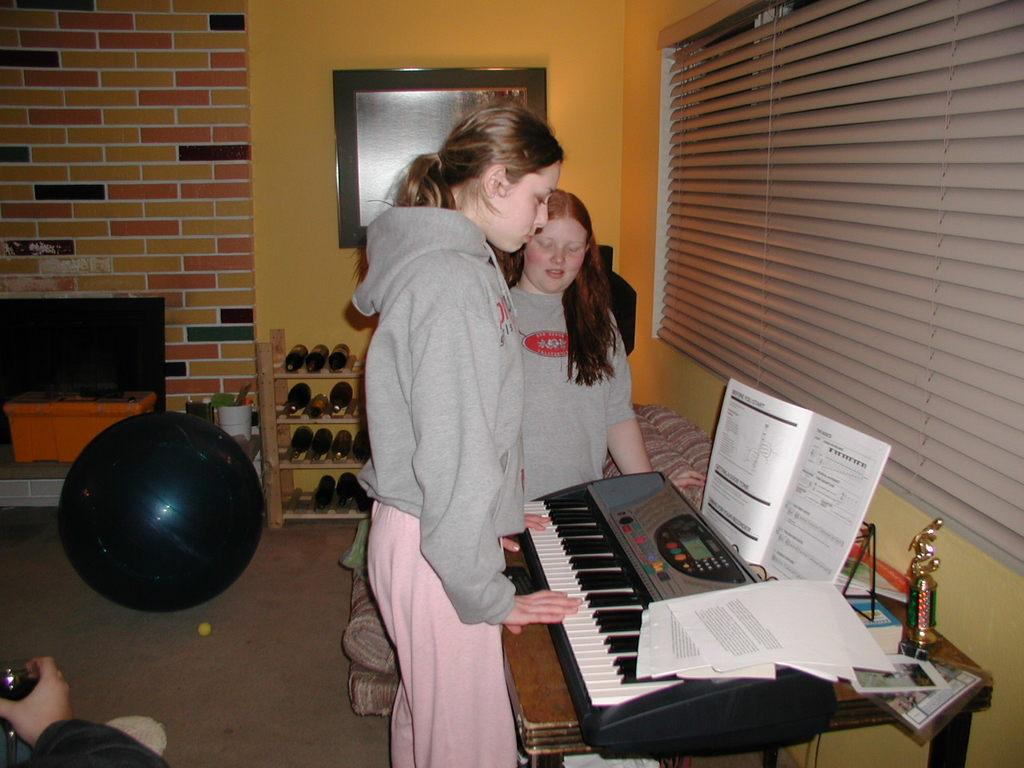What is the main subject of the image? There is a woman standing in the center of the image. What is the woman in the center doing? The woman is playing a piano. Is there anyone else in the image? Yes, there is another woman standing beside the first woman. What is the second woman doing? The second woman is looking at the piano. How many cows can be seen grazing in the background of the image? There are no cows present in the image; it features two women, one playing a piano and the other looking at the piano. 